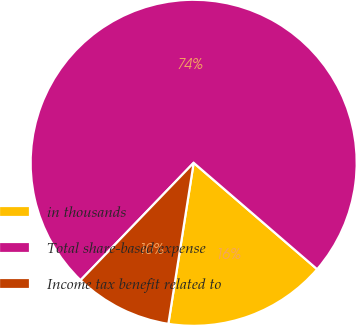Convert chart. <chart><loc_0><loc_0><loc_500><loc_500><pie_chart><fcel>in thousands<fcel>Total share-based expense<fcel>Income tax benefit related to<nl><fcel>16.16%<fcel>74.12%<fcel>9.72%<nl></chart> 